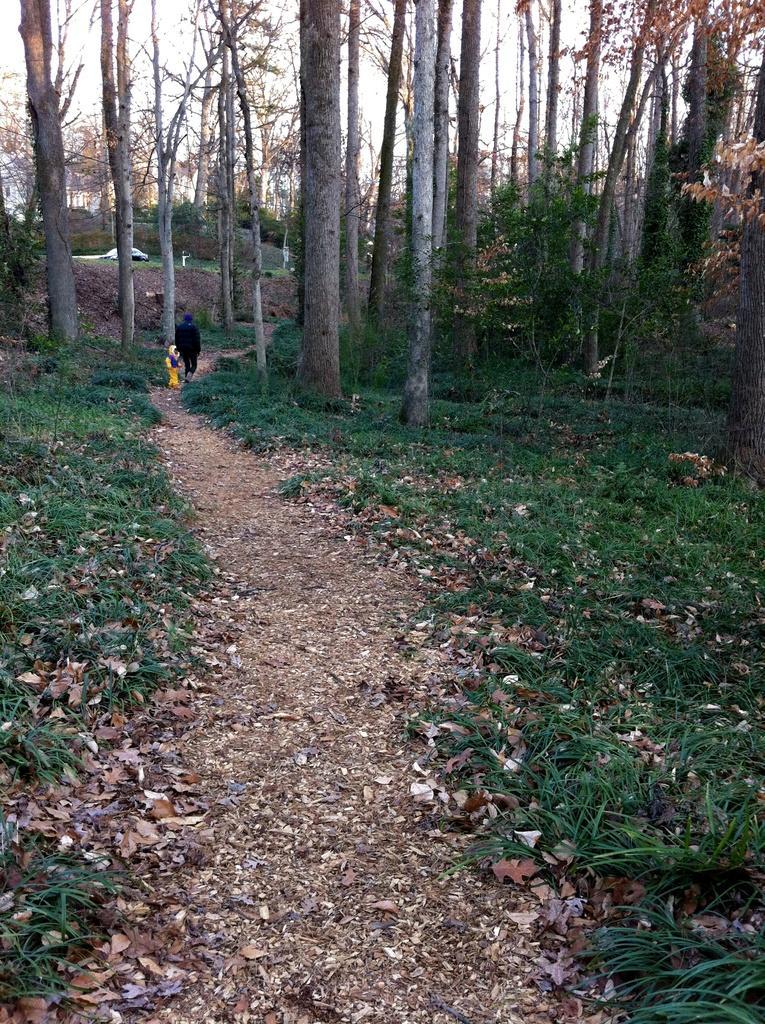Please provide a concise description of this image. In the foreground of this image, there is a path and on either side, there is grass, trees and two people are walking on the path. In the background, there are trees and the sky. 